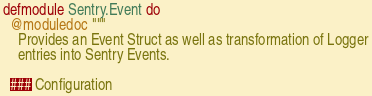<code> <loc_0><loc_0><loc_500><loc_500><_Elixir_>defmodule Sentry.Event do
  @moduledoc """
    Provides an Event Struct as well as transformation of Logger
    entries into Sentry Events.

  ### Configuration
</code> 